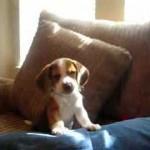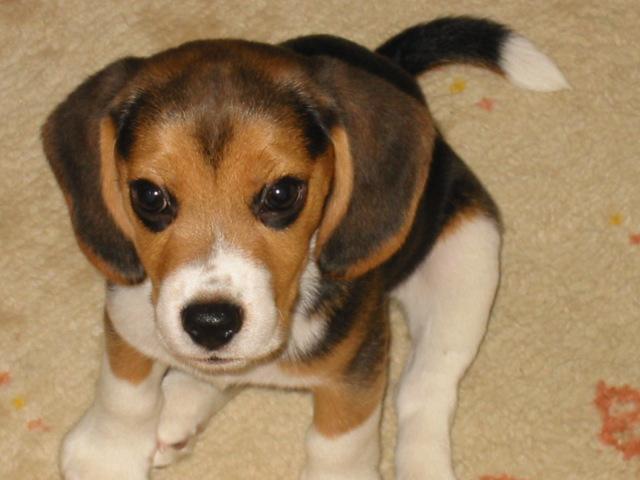The first image is the image on the left, the second image is the image on the right. Considering the images on both sides, is "All dogs' stomachs are visible." valid? Answer yes or no. No. 